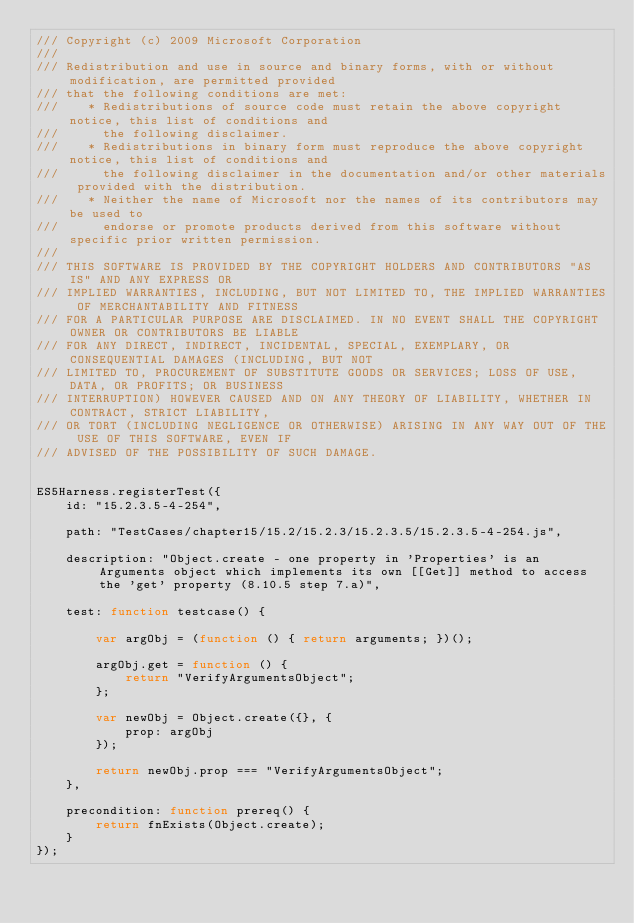<code> <loc_0><loc_0><loc_500><loc_500><_JavaScript_>/// Copyright (c) 2009 Microsoft Corporation 
/// 
/// Redistribution and use in source and binary forms, with or without modification, are permitted provided
/// that the following conditions are met: 
///    * Redistributions of source code must retain the above copyright notice, this list of conditions and
///      the following disclaimer. 
///    * Redistributions in binary form must reproduce the above copyright notice, this list of conditions and 
///      the following disclaimer in the documentation and/or other materials provided with the distribution.  
///    * Neither the name of Microsoft nor the names of its contributors may be used to
///      endorse or promote products derived from this software without specific prior written permission.
/// 
/// THIS SOFTWARE IS PROVIDED BY THE COPYRIGHT HOLDERS AND CONTRIBUTORS "AS IS" AND ANY EXPRESS OR
/// IMPLIED WARRANTIES, INCLUDING, BUT NOT LIMITED TO, THE IMPLIED WARRANTIES OF MERCHANTABILITY AND FITNESS
/// FOR A PARTICULAR PURPOSE ARE DISCLAIMED. IN NO EVENT SHALL THE COPYRIGHT OWNER OR CONTRIBUTORS BE LIABLE
/// FOR ANY DIRECT, INDIRECT, INCIDENTAL, SPECIAL, EXEMPLARY, OR CONSEQUENTIAL DAMAGES (INCLUDING, BUT NOT
/// LIMITED TO, PROCUREMENT OF SUBSTITUTE GOODS OR SERVICES; LOSS OF USE, DATA, OR PROFITS; OR BUSINESS
/// INTERRUPTION) HOWEVER CAUSED AND ON ANY THEORY OF LIABILITY, WHETHER IN CONTRACT, STRICT LIABILITY,
/// OR TORT (INCLUDING NEGLIGENCE OR OTHERWISE) ARISING IN ANY WAY OUT OF THE USE OF THIS SOFTWARE, EVEN IF
/// ADVISED OF THE POSSIBILITY OF SUCH DAMAGE.


ES5Harness.registerTest({
    id: "15.2.3.5-4-254",

    path: "TestCases/chapter15/15.2/15.2.3/15.2.3.5/15.2.3.5-4-254.js",

    description: "Object.create - one property in 'Properties' is an Arguments object which implements its own [[Get]] method to access the 'get' property (8.10.5 step 7.a)",

    test: function testcase() {

        var argObj = (function () { return arguments; })();

        argObj.get = function () {
            return "VerifyArgumentsObject";
        };

        var newObj = Object.create({}, {
            prop: argObj
        });

        return newObj.prop === "VerifyArgumentsObject";
    },

    precondition: function prereq() {
        return fnExists(Object.create);
    }
});
</code> 